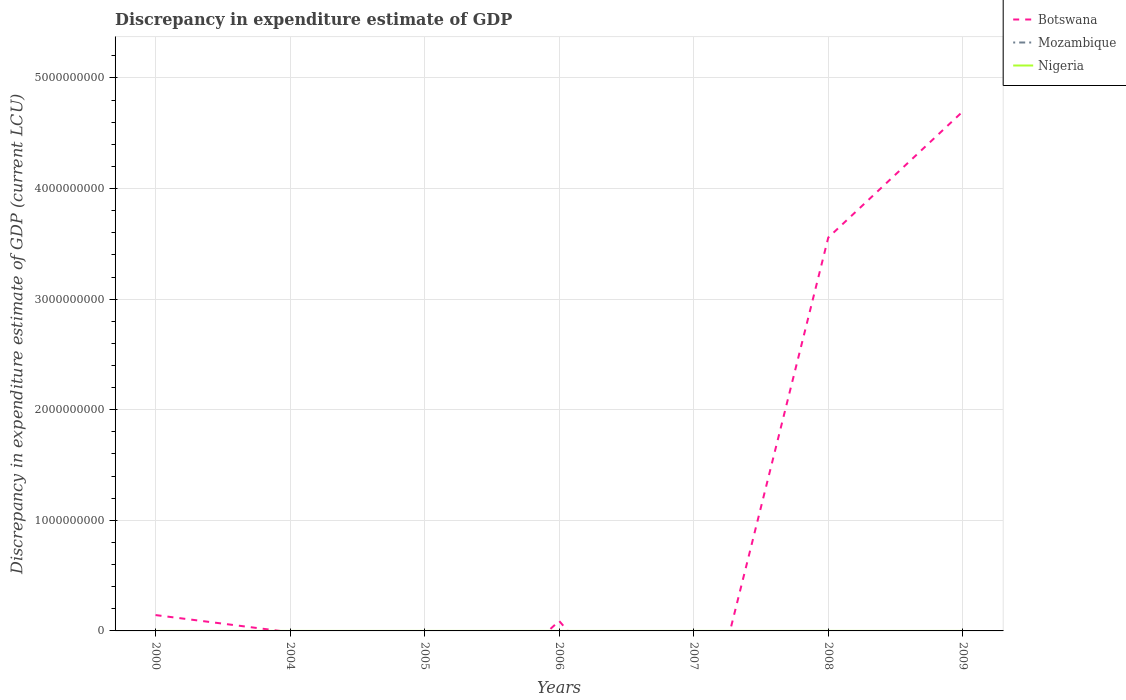How many different coloured lines are there?
Give a very brief answer. 2. Across all years, what is the maximum discrepancy in expenditure estimate of GDP in Botswana?
Give a very brief answer. 0. What is the total discrepancy in expenditure estimate of GDP in Nigeria in the graph?
Your response must be concise. -1.30e+05. What is the difference between the highest and the second highest discrepancy in expenditure estimate of GDP in Botswana?
Offer a terse response. 4.70e+09. Is the discrepancy in expenditure estimate of GDP in Botswana strictly greater than the discrepancy in expenditure estimate of GDP in Mozambique over the years?
Ensure brevity in your answer.  No. How many lines are there?
Make the answer very short. 2. How many years are there in the graph?
Ensure brevity in your answer.  7. What is the difference between two consecutive major ticks on the Y-axis?
Make the answer very short. 1.00e+09. Are the values on the major ticks of Y-axis written in scientific E-notation?
Provide a succinct answer. No. Does the graph contain any zero values?
Offer a very short reply. Yes. Does the graph contain grids?
Make the answer very short. Yes. How many legend labels are there?
Keep it short and to the point. 3. How are the legend labels stacked?
Your response must be concise. Vertical. What is the title of the graph?
Your answer should be compact. Discrepancy in expenditure estimate of GDP. What is the label or title of the X-axis?
Provide a short and direct response. Years. What is the label or title of the Y-axis?
Give a very brief answer. Discrepancy in expenditure estimate of GDP (current LCU). What is the Discrepancy in expenditure estimate of GDP (current LCU) of Botswana in 2000?
Ensure brevity in your answer.  1.43e+08. What is the Discrepancy in expenditure estimate of GDP (current LCU) of Mozambique in 2000?
Your answer should be very brief. 0. What is the Discrepancy in expenditure estimate of GDP (current LCU) in Nigeria in 2000?
Ensure brevity in your answer.  0. What is the Discrepancy in expenditure estimate of GDP (current LCU) in Nigeria in 2004?
Make the answer very short. 0. What is the Discrepancy in expenditure estimate of GDP (current LCU) in Mozambique in 2005?
Provide a short and direct response. 0. What is the Discrepancy in expenditure estimate of GDP (current LCU) in Nigeria in 2005?
Offer a terse response. 10000. What is the Discrepancy in expenditure estimate of GDP (current LCU) in Botswana in 2006?
Your response must be concise. 8.99e+07. What is the Discrepancy in expenditure estimate of GDP (current LCU) of Mozambique in 2006?
Give a very brief answer. 0. What is the Discrepancy in expenditure estimate of GDP (current LCU) in Nigeria in 2006?
Ensure brevity in your answer.  10000. What is the Discrepancy in expenditure estimate of GDP (current LCU) of Botswana in 2007?
Your answer should be very brief. 0. What is the Discrepancy in expenditure estimate of GDP (current LCU) of Nigeria in 2007?
Keep it short and to the point. 0. What is the Discrepancy in expenditure estimate of GDP (current LCU) of Botswana in 2008?
Give a very brief answer. 3.56e+09. What is the Discrepancy in expenditure estimate of GDP (current LCU) in Mozambique in 2008?
Offer a terse response. 0. What is the Discrepancy in expenditure estimate of GDP (current LCU) of Nigeria in 2008?
Your answer should be very brief. 1.40e+05. What is the Discrepancy in expenditure estimate of GDP (current LCU) in Botswana in 2009?
Make the answer very short. 4.70e+09. What is the Discrepancy in expenditure estimate of GDP (current LCU) of Mozambique in 2009?
Make the answer very short. 0. What is the Discrepancy in expenditure estimate of GDP (current LCU) in Nigeria in 2009?
Your response must be concise. 0. Across all years, what is the maximum Discrepancy in expenditure estimate of GDP (current LCU) in Botswana?
Keep it short and to the point. 4.70e+09. Across all years, what is the maximum Discrepancy in expenditure estimate of GDP (current LCU) of Nigeria?
Keep it short and to the point. 1.40e+05. What is the total Discrepancy in expenditure estimate of GDP (current LCU) of Botswana in the graph?
Ensure brevity in your answer.  8.49e+09. What is the total Discrepancy in expenditure estimate of GDP (current LCU) in Mozambique in the graph?
Offer a very short reply. 0. What is the total Discrepancy in expenditure estimate of GDP (current LCU) of Nigeria in the graph?
Make the answer very short. 1.60e+05. What is the difference between the Discrepancy in expenditure estimate of GDP (current LCU) of Botswana in 2000 and that in 2006?
Offer a very short reply. 5.34e+07. What is the difference between the Discrepancy in expenditure estimate of GDP (current LCU) of Botswana in 2000 and that in 2008?
Offer a very short reply. -3.41e+09. What is the difference between the Discrepancy in expenditure estimate of GDP (current LCU) in Botswana in 2000 and that in 2009?
Provide a succinct answer. -4.55e+09. What is the difference between the Discrepancy in expenditure estimate of GDP (current LCU) in Nigeria in 2005 and that in 2008?
Offer a very short reply. -1.30e+05. What is the difference between the Discrepancy in expenditure estimate of GDP (current LCU) in Botswana in 2006 and that in 2008?
Provide a short and direct response. -3.47e+09. What is the difference between the Discrepancy in expenditure estimate of GDP (current LCU) in Nigeria in 2006 and that in 2008?
Your answer should be very brief. -1.30e+05. What is the difference between the Discrepancy in expenditure estimate of GDP (current LCU) of Botswana in 2006 and that in 2009?
Provide a succinct answer. -4.61e+09. What is the difference between the Discrepancy in expenditure estimate of GDP (current LCU) of Botswana in 2008 and that in 2009?
Make the answer very short. -1.14e+09. What is the difference between the Discrepancy in expenditure estimate of GDP (current LCU) in Botswana in 2000 and the Discrepancy in expenditure estimate of GDP (current LCU) in Nigeria in 2005?
Ensure brevity in your answer.  1.43e+08. What is the difference between the Discrepancy in expenditure estimate of GDP (current LCU) of Botswana in 2000 and the Discrepancy in expenditure estimate of GDP (current LCU) of Nigeria in 2006?
Offer a very short reply. 1.43e+08. What is the difference between the Discrepancy in expenditure estimate of GDP (current LCU) of Botswana in 2000 and the Discrepancy in expenditure estimate of GDP (current LCU) of Nigeria in 2008?
Make the answer very short. 1.43e+08. What is the difference between the Discrepancy in expenditure estimate of GDP (current LCU) in Botswana in 2006 and the Discrepancy in expenditure estimate of GDP (current LCU) in Nigeria in 2008?
Ensure brevity in your answer.  8.98e+07. What is the average Discrepancy in expenditure estimate of GDP (current LCU) in Botswana per year?
Provide a succinct answer. 1.21e+09. What is the average Discrepancy in expenditure estimate of GDP (current LCU) of Nigeria per year?
Give a very brief answer. 2.29e+04. In the year 2006, what is the difference between the Discrepancy in expenditure estimate of GDP (current LCU) of Botswana and Discrepancy in expenditure estimate of GDP (current LCU) of Nigeria?
Give a very brief answer. 8.99e+07. In the year 2008, what is the difference between the Discrepancy in expenditure estimate of GDP (current LCU) in Botswana and Discrepancy in expenditure estimate of GDP (current LCU) in Nigeria?
Offer a terse response. 3.56e+09. What is the ratio of the Discrepancy in expenditure estimate of GDP (current LCU) of Botswana in 2000 to that in 2006?
Provide a succinct answer. 1.59. What is the ratio of the Discrepancy in expenditure estimate of GDP (current LCU) in Botswana in 2000 to that in 2008?
Offer a terse response. 0.04. What is the ratio of the Discrepancy in expenditure estimate of GDP (current LCU) of Botswana in 2000 to that in 2009?
Make the answer very short. 0.03. What is the ratio of the Discrepancy in expenditure estimate of GDP (current LCU) in Nigeria in 2005 to that in 2008?
Your answer should be compact. 0.07. What is the ratio of the Discrepancy in expenditure estimate of GDP (current LCU) in Botswana in 2006 to that in 2008?
Provide a succinct answer. 0.03. What is the ratio of the Discrepancy in expenditure estimate of GDP (current LCU) in Nigeria in 2006 to that in 2008?
Offer a terse response. 0.07. What is the ratio of the Discrepancy in expenditure estimate of GDP (current LCU) in Botswana in 2006 to that in 2009?
Your answer should be very brief. 0.02. What is the ratio of the Discrepancy in expenditure estimate of GDP (current LCU) of Botswana in 2008 to that in 2009?
Keep it short and to the point. 0.76. What is the difference between the highest and the second highest Discrepancy in expenditure estimate of GDP (current LCU) in Botswana?
Make the answer very short. 1.14e+09. What is the difference between the highest and the second highest Discrepancy in expenditure estimate of GDP (current LCU) of Nigeria?
Your answer should be compact. 1.30e+05. What is the difference between the highest and the lowest Discrepancy in expenditure estimate of GDP (current LCU) in Botswana?
Give a very brief answer. 4.70e+09. What is the difference between the highest and the lowest Discrepancy in expenditure estimate of GDP (current LCU) of Nigeria?
Keep it short and to the point. 1.40e+05. 